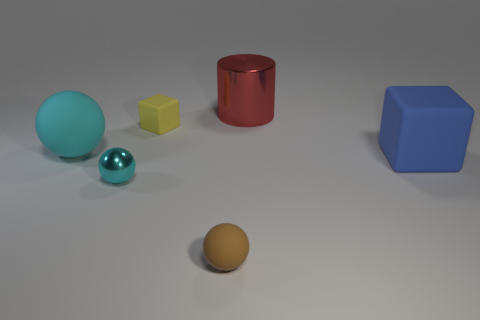Which objects in the image are glossy and what are their colors? In the image, there are two objects that exhibit a glossy texture. One is a sphere that has a cyan-like blue color, and the other is a cylinder which is red. These glossy items contrast with the other matte surfaces present. 